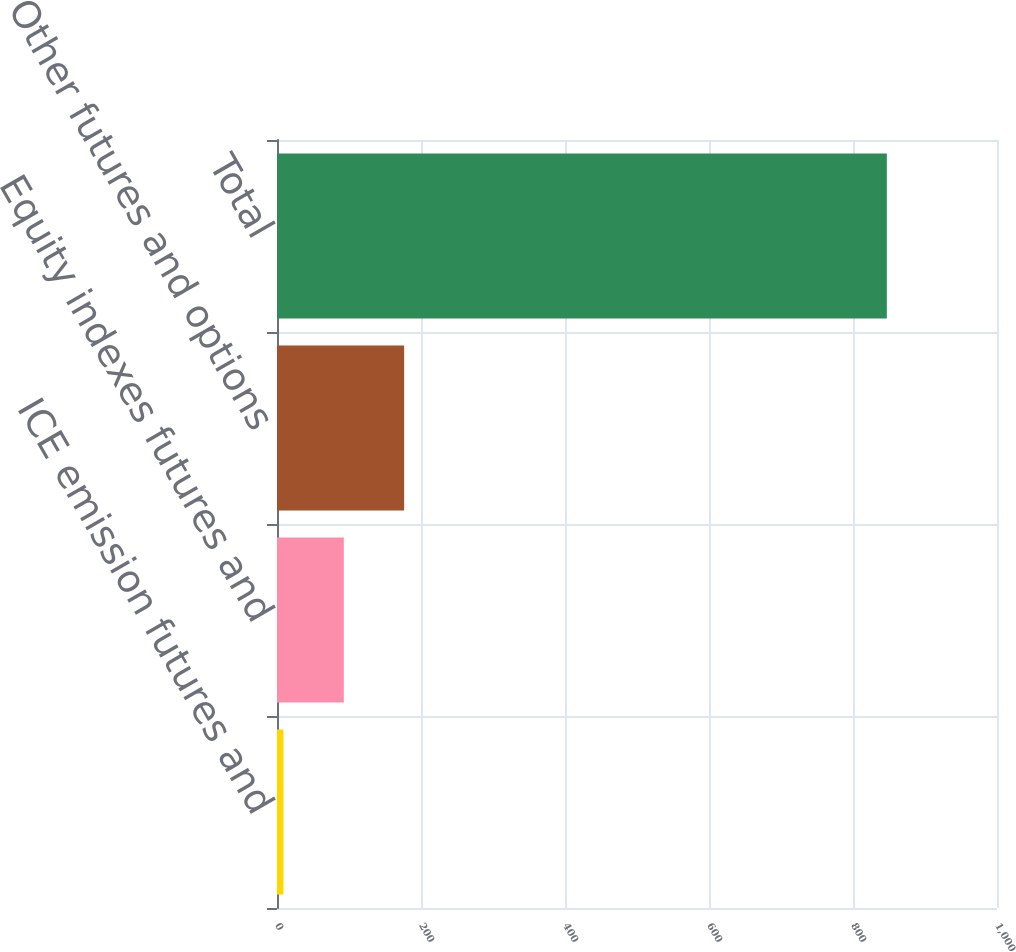<chart> <loc_0><loc_0><loc_500><loc_500><bar_chart><fcel>ICE emission futures and<fcel>Equity indexes futures and<fcel>Other futures and options<fcel>Total<nl><fcel>9<fcel>92.8<fcel>176.6<fcel>847<nl></chart> 